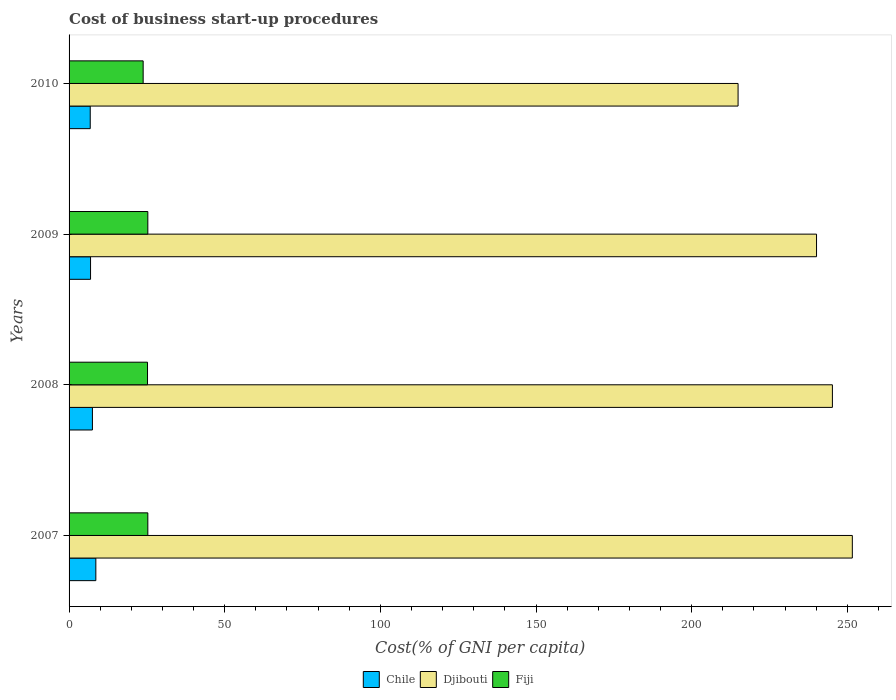How many different coloured bars are there?
Your response must be concise. 3. How many groups of bars are there?
Your answer should be very brief. 4. Are the number of bars per tick equal to the number of legend labels?
Offer a very short reply. Yes. How many bars are there on the 4th tick from the bottom?
Keep it short and to the point. 3. What is the cost of business start-up procedures in Chile in 2008?
Provide a short and direct response. 7.5. Across all years, what is the maximum cost of business start-up procedures in Chile?
Give a very brief answer. 8.6. Across all years, what is the minimum cost of business start-up procedures in Djibouti?
Give a very brief answer. 214.9. In which year was the cost of business start-up procedures in Fiji maximum?
Keep it short and to the point. 2007. In which year was the cost of business start-up procedures in Fiji minimum?
Give a very brief answer. 2010. What is the total cost of business start-up procedures in Fiji in the graph?
Provide a succinct answer. 99.6. What is the difference between the cost of business start-up procedures in Chile in 2007 and that in 2008?
Offer a terse response. 1.1. What is the difference between the cost of business start-up procedures in Djibouti in 2010 and the cost of business start-up procedures in Fiji in 2009?
Ensure brevity in your answer.  189.6. What is the average cost of business start-up procedures in Chile per year?
Provide a short and direct response. 7.45. In the year 2007, what is the difference between the cost of business start-up procedures in Fiji and cost of business start-up procedures in Djibouti?
Your answer should be compact. -226.3. In how many years, is the cost of business start-up procedures in Djibouti greater than 100 %?
Keep it short and to the point. 4. What is the ratio of the cost of business start-up procedures in Djibouti in 2009 to that in 2010?
Your answer should be very brief. 1.12. Is the cost of business start-up procedures in Chile in 2008 less than that in 2010?
Make the answer very short. No. Is the difference between the cost of business start-up procedures in Fiji in 2007 and 2008 greater than the difference between the cost of business start-up procedures in Djibouti in 2007 and 2008?
Your answer should be very brief. No. What is the difference between the highest and the second highest cost of business start-up procedures in Fiji?
Ensure brevity in your answer.  0. What is the difference between the highest and the lowest cost of business start-up procedures in Djibouti?
Your response must be concise. 36.7. In how many years, is the cost of business start-up procedures in Djibouti greater than the average cost of business start-up procedures in Djibouti taken over all years?
Provide a short and direct response. 3. What does the 2nd bar from the top in 2007 represents?
Your answer should be very brief. Djibouti. What does the 3rd bar from the bottom in 2007 represents?
Your answer should be compact. Fiji. Is it the case that in every year, the sum of the cost of business start-up procedures in Fiji and cost of business start-up procedures in Djibouti is greater than the cost of business start-up procedures in Chile?
Your response must be concise. Yes. How many years are there in the graph?
Provide a short and direct response. 4. What is the difference between two consecutive major ticks on the X-axis?
Offer a very short reply. 50. Are the values on the major ticks of X-axis written in scientific E-notation?
Give a very brief answer. No. Does the graph contain grids?
Your answer should be compact. No. How many legend labels are there?
Keep it short and to the point. 3. How are the legend labels stacked?
Provide a succinct answer. Horizontal. What is the title of the graph?
Your response must be concise. Cost of business start-up procedures. Does "Monaco" appear as one of the legend labels in the graph?
Offer a very short reply. No. What is the label or title of the X-axis?
Your answer should be compact. Cost(% of GNI per capita). What is the label or title of the Y-axis?
Keep it short and to the point. Years. What is the Cost(% of GNI per capita) of Chile in 2007?
Your answer should be very brief. 8.6. What is the Cost(% of GNI per capita) in Djibouti in 2007?
Offer a very short reply. 251.6. What is the Cost(% of GNI per capita) in Fiji in 2007?
Your answer should be very brief. 25.3. What is the Cost(% of GNI per capita) of Chile in 2008?
Offer a terse response. 7.5. What is the Cost(% of GNI per capita) of Djibouti in 2008?
Give a very brief answer. 245.2. What is the Cost(% of GNI per capita) in Fiji in 2008?
Give a very brief answer. 25.2. What is the Cost(% of GNI per capita) of Djibouti in 2009?
Ensure brevity in your answer.  240.1. What is the Cost(% of GNI per capita) of Fiji in 2009?
Provide a succinct answer. 25.3. What is the Cost(% of GNI per capita) in Djibouti in 2010?
Ensure brevity in your answer.  214.9. What is the Cost(% of GNI per capita) in Fiji in 2010?
Ensure brevity in your answer.  23.8. Across all years, what is the maximum Cost(% of GNI per capita) in Djibouti?
Make the answer very short. 251.6. Across all years, what is the maximum Cost(% of GNI per capita) of Fiji?
Ensure brevity in your answer.  25.3. Across all years, what is the minimum Cost(% of GNI per capita) in Djibouti?
Make the answer very short. 214.9. Across all years, what is the minimum Cost(% of GNI per capita) of Fiji?
Provide a succinct answer. 23.8. What is the total Cost(% of GNI per capita) in Chile in the graph?
Offer a very short reply. 29.8. What is the total Cost(% of GNI per capita) in Djibouti in the graph?
Provide a short and direct response. 951.8. What is the total Cost(% of GNI per capita) in Fiji in the graph?
Provide a succinct answer. 99.6. What is the difference between the Cost(% of GNI per capita) in Djibouti in 2007 and that in 2008?
Provide a succinct answer. 6.4. What is the difference between the Cost(% of GNI per capita) in Fiji in 2007 and that in 2008?
Offer a terse response. 0.1. What is the difference between the Cost(% of GNI per capita) in Chile in 2007 and that in 2009?
Provide a succinct answer. 1.7. What is the difference between the Cost(% of GNI per capita) of Djibouti in 2007 and that in 2009?
Keep it short and to the point. 11.5. What is the difference between the Cost(% of GNI per capita) of Chile in 2007 and that in 2010?
Your answer should be compact. 1.8. What is the difference between the Cost(% of GNI per capita) in Djibouti in 2007 and that in 2010?
Offer a very short reply. 36.7. What is the difference between the Cost(% of GNI per capita) of Djibouti in 2008 and that in 2009?
Ensure brevity in your answer.  5.1. What is the difference between the Cost(% of GNI per capita) in Fiji in 2008 and that in 2009?
Provide a short and direct response. -0.1. What is the difference between the Cost(% of GNI per capita) of Chile in 2008 and that in 2010?
Ensure brevity in your answer.  0.7. What is the difference between the Cost(% of GNI per capita) of Djibouti in 2008 and that in 2010?
Make the answer very short. 30.3. What is the difference between the Cost(% of GNI per capita) in Fiji in 2008 and that in 2010?
Ensure brevity in your answer.  1.4. What is the difference between the Cost(% of GNI per capita) in Chile in 2009 and that in 2010?
Your answer should be compact. 0.1. What is the difference between the Cost(% of GNI per capita) of Djibouti in 2009 and that in 2010?
Your answer should be compact. 25.2. What is the difference between the Cost(% of GNI per capita) of Chile in 2007 and the Cost(% of GNI per capita) of Djibouti in 2008?
Ensure brevity in your answer.  -236.6. What is the difference between the Cost(% of GNI per capita) of Chile in 2007 and the Cost(% of GNI per capita) of Fiji in 2008?
Ensure brevity in your answer.  -16.6. What is the difference between the Cost(% of GNI per capita) of Djibouti in 2007 and the Cost(% of GNI per capita) of Fiji in 2008?
Offer a very short reply. 226.4. What is the difference between the Cost(% of GNI per capita) of Chile in 2007 and the Cost(% of GNI per capita) of Djibouti in 2009?
Provide a succinct answer. -231.5. What is the difference between the Cost(% of GNI per capita) in Chile in 2007 and the Cost(% of GNI per capita) in Fiji in 2009?
Keep it short and to the point. -16.7. What is the difference between the Cost(% of GNI per capita) in Djibouti in 2007 and the Cost(% of GNI per capita) in Fiji in 2009?
Offer a terse response. 226.3. What is the difference between the Cost(% of GNI per capita) in Chile in 2007 and the Cost(% of GNI per capita) in Djibouti in 2010?
Provide a succinct answer. -206.3. What is the difference between the Cost(% of GNI per capita) of Chile in 2007 and the Cost(% of GNI per capita) of Fiji in 2010?
Offer a very short reply. -15.2. What is the difference between the Cost(% of GNI per capita) of Djibouti in 2007 and the Cost(% of GNI per capita) of Fiji in 2010?
Your response must be concise. 227.8. What is the difference between the Cost(% of GNI per capita) of Chile in 2008 and the Cost(% of GNI per capita) of Djibouti in 2009?
Offer a terse response. -232.6. What is the difference between the Cost(% of GNI per capita) of Chile in 2008 and the Cost(% of GNI per capita) of Fiji in 2009?
Keep it short and to the point. -17.8. What is the difference between the Cost(% of GNI per capita) in Djibouti in 2008 and the Cost(% of GNI per capita) in Fiji in 2009?
Your response must be concise. 219.9. What is the difference between the Cost(% of GNI per capita) in Chile in 2008 and the Cost(% of GNI per capita) in Djibouti in 2010?
Give a very brief answer. -207.4. What is the difference between the Cost(% of GNI per capita) of Chile in 2008 and the Cost(% of GNI per capita) of Fiji in 2010?
Your answer should be very brief. -16.3. What is the difference between the Cost(% of GNI per capita) of Djibouti in 2008 and the Cost(% of GNI per capita) of Fiji in 2010?
Give a very brief answer. 221.4. What is the difference between the Cost(% of GNI per capita) in Chile in 2009 and the Cost(% of GNI per capita) in Djibouti in 2010?
Offer a terse response. -208. What is the difference between the Cost(% of GNI per capita) in Chile in 2009 and the Cost(% of GNI per capita) in Fiji in 2010?
Make the answer very short. -16.9. What is the difference between the Cost(% of GNI per capita) in Djibouti in 2009 and the Cost(% of GNI per capita) in Fiji in 2010?
Keep it short and to the point. 216.3. What is the average Cost(% of GNI per capita) of Chile per year?
Keep it short and to the point. 7.45. What is the average Cost(% of GNI per capita) in Djibouti per year?
Your answer should be compact. 237.95. What is the average Cost(% of GNI per capita) in Fiji per year?
Keep it short and to the point. 24.9. In the year 2007, what is the difference between the Cost(% of GNI per capita) of Chile and Cost(% of GNI per capita) of Djibouti?
Give a very brief answer. -243. In the year 2007, what is the difference between the Cost(% of GNI per capita) in Chile and Cost(% of GNI per capita) in Fiji?
Your answer should be compact. -16.7. In the year 2007, what is the difference between the Cost(% of GNI per capita) of Djibouti and Cost(% of GNI per capita) of Fiji?
Provide a succinct answer. 226.3. In the year 2008, what is the difference between the Cost(% of GNI per capita) of Chile and Cost(% of GNI per capita) of Djibouti?
Keep it short and to the point. -237.7. In the year 2008, what is the difference between the Cost(% of GNI per capita) in Chile and Cost(% of GNI per capita) in Fiji?
Give a very brief answer. -17.7. In the year 2008, what is the difference between the Cost(% of GNI per capita) in Djibouti and Cost(% of GNI per capita) in Fiji?
Provide a short and direct response. 220. In the year 2009, what is the difference between the Cost(% of GNI per capita) in Chile and Cost(% of GNI per capita) in Djibouti?
Offer a terse response. -233.2. In the year 2009, what is the difference between the Cost(% of GNI per capita) in Chile and Cost(% of GNI per capita) in Fiji?
Make the answer very short. -18.4. In the year 2009, what is the difference between the Cost(% of GNI per capita) of Djibouti and Cost(% of GNI per capita) of Fiji?
Provide a succinct answer. 214.8. In the year 2010, what is the difference between the Cost(% of GNI per capita) of Chile and Cost(% of GNI per capita) of Djibouti?
Your answer should be very brief. -208.1. In the year 2010, what is the difference between the Cost(% of GNI per capita) in Djibouti and Cost(% of GNI per capita) in Fiji?
Provide a short and direct response. 191.1. What is the ratio of the Cost(% of GNI per capita) in Chile in 2007 to that in 2008?
Your response must be concise. 1.15. What is the ratio of the Cost(% of GNI per capita) in Djibouti in 2007 to that in 2008?
Offer a terse response. 1.03. What is the ratio of the Cost(% of GNI per capita) in Chile in 2007 to that in 2009?
Your answer should be compact. 1.25. What is the ratio of the Cost(% of GNI per capita) of Djibouti in 2007 to that in 2009?
Provide a succinct answer. 1.05. What is the ratio of the Cost(% of GNI per capita) in Chile in 2007 to that in 2010?
Provide a short and direct response. 1.26. What is the ratio of the Cost(% of GNI per capita) of Djibouti in 2007 to that in 2010?
Provide a short and direct response. 1.17. What is the ratio of the Cost(% of GNI per capita) in Fiji in 2007 to that in 2010?
Ensure brevity in your answer.  1.06. What is the ratio of the Cost(% of GNI per capita) of Chile in 2008 to that in 2009?
Your answer should be compact. 1.09. What is the ratio of the Cost(% of GNI per capita) in Djibouti in 2008 to that in 2009?
Your answer should be compact. 1.02. What is the ratio of the Cost(% of GNI per capita) in Fiji in 2008 to that in 2009?
Offer a terse response. 1. What is the ratio of the Cost(% of GNI per capita) in Chile in 2008 to that in 2010?
Your answer should be compact. 1.1. What is the ratio of the Cost(% of GNI per capita) in Djibouti in 2008 to that in 2010?
Provide a short and direct response. 1.14. What is the ratio of the Cost(% of GNI per capita) in Fiji in 2008 to that in 2010?
Your answer should be very brief. 1.06. What is the ratio of the Cost(% of GNI per capita) in Chile in 2009 to that in 2010?
Your answer should be very brief. 1.01. What is the ratio of the Cost(% of GNI per capita) in Djibouti in 2009 to that in 2010?
Ensure brevity in your answer.  1.12. What is the ratio of the Cost(% of GNI per capita) of Fiji in 2009 to that in 2010?
Provide a short and direct response. 1.06. What is the difference between the highest and the lowest Cost(% of GNI per capita) of Chile?
Offer a terse response. 1.8. What is the difference between the highest and the lowest Cost(% of GNI per capita) of Djibouti?
Make the answer very short. 36.7. 